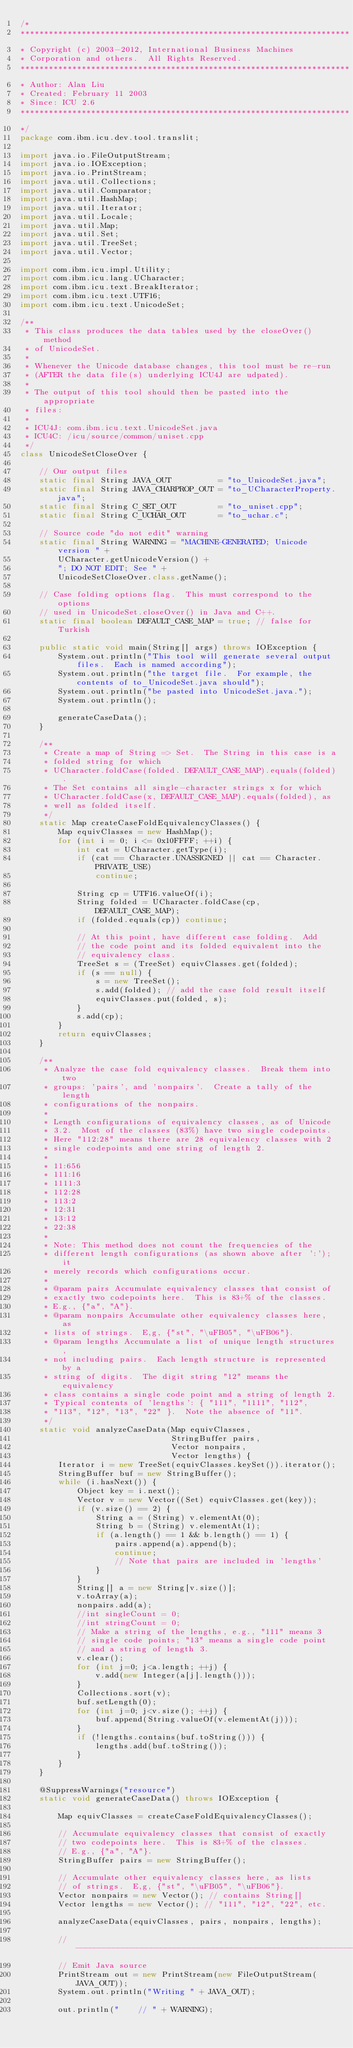<code> <loc_0><loc_0><loc_500><loc_500><_Java_>/*
**********************************************************************
* Copyright (c) 2003-2012, International Business Machines
* Corporation and others.  All Rights Reserved.
**********************************************************************
* Author: Alan Liu
* Created: February 11 2003
* Since: ICU 2.6
**********************************************************************
*/
package com.ibm.icu.dev.tool.translit;

import java.io.FileOutputStream;
import java.io.IOException;
import java.io.PrintStream;
import java.util.Collections;
import java.util.Comparator;
import java.util.HashMap;
import java.util.Iterator;
import java.util.Locale;
import java.util.Map;
import java.util.Set;
import java.util.TreeSet;
import java.util.Vector;

import com.ibm.icu.impl.Utility;
import com.ibm.icu.lang.UCharacter;
import com.ibm.icu.text.BreakIterator;
import com.ibm.icu.text.UTF16;
import com.ibm.icu.text.UnicodeSet;

/**
 * This class produces the data tables used by the closeOver() method
 * of UnicodeSet.
 *
 * Whenever the Unicode database changes, this tool must be re-run
 * (AFTER the data file(s) underlying ICU4J are udpated).
 *
 * The output of this tool should then be pasted into the appropriate
 * files:
 *
 * ICU4J: com.ibm.icu.text.UnicodeSet.java
 * ICU4C: /icu/source/common/uniset.cpp
 */
class UnicodeSetCloseOver {

    // Our output files
    static final String JAVA_OUT          = "to_UnicodeSet.java";
    static final String JAVA_CHARPROP_OUT = "to_UCharacterProperty.java";
    static final String C_SET_OUT         = "to_uniset.cpp";
    static final String C_UCHAR_OUT       = "to_uchar.c";

    // Source code "do not edit" warning
    static final String WARNING = "MACHINE-GENERATED; Unicode version " +
        UCharacter.getUnicodeVersion() +
        "; DO NOT EDIT; See " +
        UnicodeSetCloseOver.class.getName();

    // Case folding options flag.  This must correspond to the options
    // used in UnicodeSet.closeOver() in Java and C++.
    static final boolean DEFAULT_CASE_MAP = true; // false for Turkish

    public static void main(String[] args) throws IOException {
        System.out.println("This tool will generate several output files.  Each is named according");
        System.out.println("the target file.  For example, the contents of to_UnicodeSet.java should");
        System.out.println("be pasted into UnicodeSet.java.");
        System.out.println();

        generateCaseData();
    }

    /**
     * Create a map of String => Set.  The String in this case is a
     * folded string for which
     * UCharacter.foldCase(folded. DEFAULT_CASE_MAP).equals(folded).
     * The Set contains all single-character strings x for which
     * UCharacter.foldCase(x, DEFAULT_CASE_MAP).equals(folded), as
     * well as folded itself.
     */
    static Map createCaseFoldEquivalencyClasses() {
        Map equivClasses = new HashMap();
        for (int i = 0; i <= 0x10FFFF; ++i) {
            int cat = UCharacter.getType(i);
            if (cat == Character.UNASSIGNED || cat == Character.PRIVATE_USE)
                continue;

            String cp = UTF16.valueOf(i);
            String folded = UCharacter.foldCase(cp, DEFAULT_CASE_MAP);
            if (folded.equals(cp)) continue;

            // At this point, have different case folding.  Add
            // the code point and its folded equivalent into the
            // equivalency class.
            TreeSet s = (TreeSet) equivClasses.get(folded);
            if (s == null) {
                s = new TreeSet();
                s.add(folded); // add the case fold result itself
                equivClasses.put(folded, s);
            }
            s.add(cp);
        }
        return equivClasses;
    }

    /**
     * Analyze the case fold equivalency classes.  Break them into two
     * groups: 'pairs', and 'nonpairs'.  Create a tally of the length
     * configurations of the nonpairs.
     *
     * Length configurations of equivalency classes, as of Unicode
     * 3.2.  Most of the classes (83%) have two single codepoints.
     * Here "112:28" means there are 28 equivalency classes with 2
     * single codepoints and one string of length 2.
     *
     * 11:656
     * 111:16
     * 1111:3
     * 112:28
     * 113:2
     * 12:31
     * 13:12
     * 22:38
     *
     * Note: This method does not count the frequencies of the
     * different length configurations (as shown above after ':'); it
     * merely records which configurations occur.
     *
     * @param pairs Accumulate equivalency classes that consist of
     * exactly two codepoints here.  This is 83+% of the classes.
     * E.g., {"a", "A"}.
     * @param nonpairs Accumulate other equivalency classes here, as
     * lists of strings.  E,g, {"st", "\uFB05", "\uFB06"}.
     * @param lengths Accumulate a list of unique length structures,
     * not including pairs.  Each length structure is represented by a
     * string of digits.  The digit string "12" means the equivalency
     * class contains a single code point and a string of length 2.
     * Typical contents of 'lengths': { "111", "1111", "112",
     * "113", "12", "13", "22" }.  Note the absence of "11".
     */
    static void analyzeCaseData(Map equivClasses,
                                StringBuffer pairs,
                                Vector nonpairs,
                                Vector lengths) {
        Iterator i = new TreeSet(equivClasses.keySet()).iterator();
        StringBuffer buf = new StringBuffer();
        while (i.hasNext()) {
            Object key = i.next();
            Vector v = new Vector((Set) equivClasses.get(key));
            if (v.size() == 2) {
                String a = (String) v.elementAt(0);
                String b = (String) v.elementAt(1);
                if (a.length() == 1 && b.length() == 1) {
                    pairs.append(a).append(b);
                    continue;
                    // Note that pairs are included in 'lengths'
                }
            }
            String[] a = new String[v.size()];
            v.toArray(a);
            nonpairs.add(a);
            //int singleCount = 0;
            //int stringCount = 0;
            // Make a string of the lengths, e.g., "111" means 3
            // single code points; "13" means a single code point
            // and a string of length 3.
            v.clear();
            for (int j=0; j<a.length; ++j) {
                v.add(new Integer(a[j].length()));
            }
            Collections.sort(v);
            buf.setLength(0);
            for (int j=0; j<v.size(); ++j) {
                buf.append(String.valueOf(v.elementAt(j)));
            }
            if (!lengths.contains(buf.toString())) {
                lengths.add(buf.toString());
            }
        }
    }

    @SuppressWarnings("resource")
    static void generateCaseData() throws IOException {

        Map equivClasses = createCaseFoldEquivalencyClasses();

        // Accumulate equivalency classes that consist of exactly
        // two codepoints here.  This is 83+% of the classes.
        // E.g., {"a", "A"}.
        StringBuffer pairs = new StringBuffer();

        // Accumulate other equivalency classes here, as lists
        // of strings.  E,g, {"st", "\uFB05", "\uFB06"}.
        Vector nonpairs = new Vector(); // contains String[]
        Vector lengths = new Vector(); // "111", "12", "22", etc.

        analyzeCaseData(equivClasses, pairs, nonpairs, lengths);

        //-------------------------------------------------------------
        // Emit Java source
        PrintStream out = new PrintStream(new FileOutputStream(JAVA_OUT));
        System.out.println("Writing " + JAVA_OUT);

        out.println("    // " + WARNING);</code> 